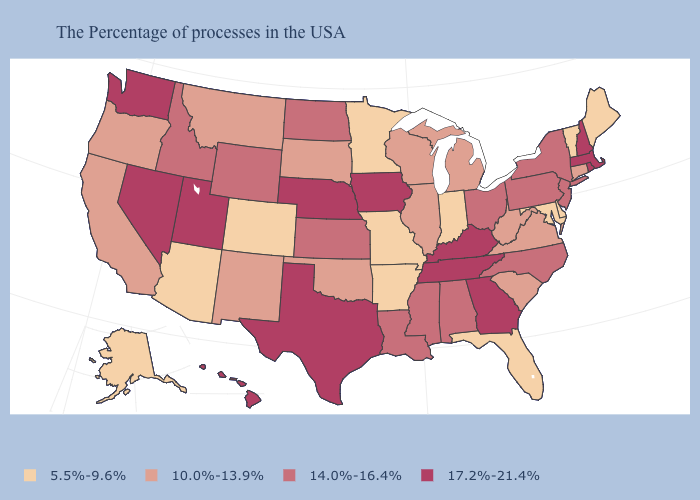Does the map have missing data?
Be succinct. No. What is the value of Idaho?
Quick response, please. 14.0%-16.4%. Which states have the lowest value in the MidWest?
Concise answer only. Indiana, Missouri, Minnesota. Which states have the lowest value in the Northeast?
Quick response, please. Maine, Vermont. Does New York have a lower value than Minnesota?
Be succinct. No. Name the states that have a value in the range 10.0%-13.9%?
Answer briefly. Connecticut, Virginia, South Carolina, West Virginia, Michigan, Wisconsin, Illinois, Oklahoma, South Dakota, New Mexico, Montana, California, Oregon. What is the highest value in the Northeast ?
Be succinct. 17.2%-21.4%. Does New Mexico have the same value as California?
Write a very short answer. Yes. Name the states that have a value in the range 10.0%-13.9%?
Answer briefly. Connecticut, Virginia, South Carolina, West Virginia, Michigan, Wisconsin, Illinois, Oklahoma, South Dakota, New Mexico, Montana, California, Oregon. How many symbols are there in the legend?
Short answer required. 4. Does Massachusetts have the highest value in the USA?
Give a very brief answer. Yes. Name the states that have a value in the range 10.0%-13.9%?
Be succinct. Connecticut, Virginia, South Carolina, West Virginia, Michigan, Wisconsin, Illinois, Oklahoma, South Dakota, New Mexico, Montana, California, Oregon. Which states have the lowest value in the Northeast?
Answer briefly. Maine, Vermont. Which states have the lowest value in the MidWest?
Quick response, please. Indiana, Missouri, Minnesota. Among the states that border Maryland , which have the highest value?
Concise answer only. Pennsylvania. 